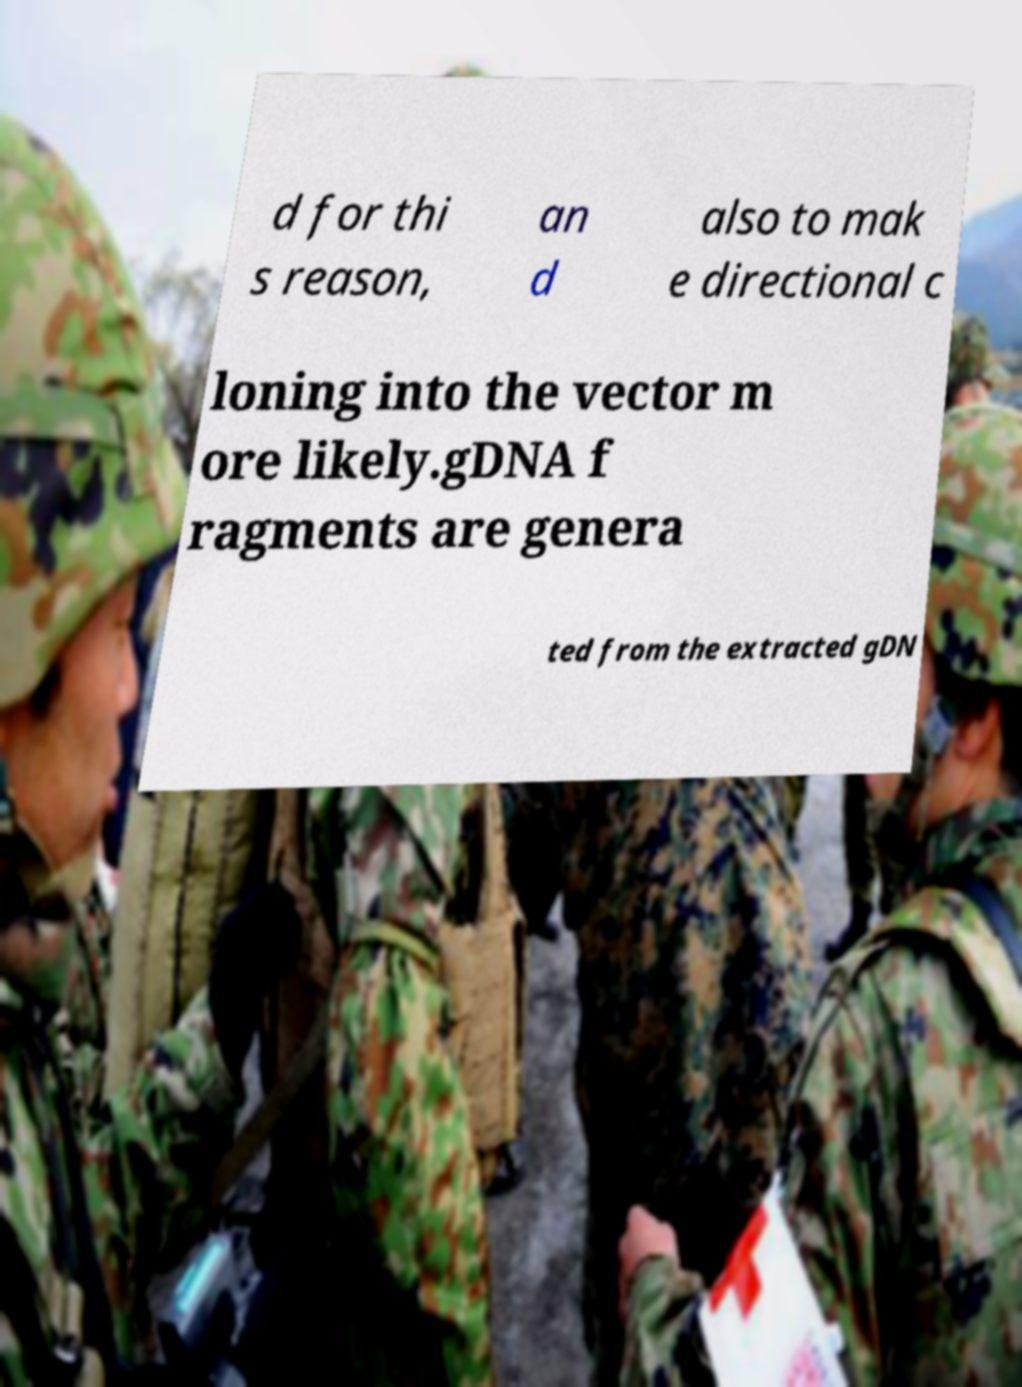For documentation purposes, I need the text within this image transcribed. Could you provide that? d for thi s reason, an d also to mak e directional c loning into the vector m ore likely.gDNA f ragments are genera ted from the extracted gDN 